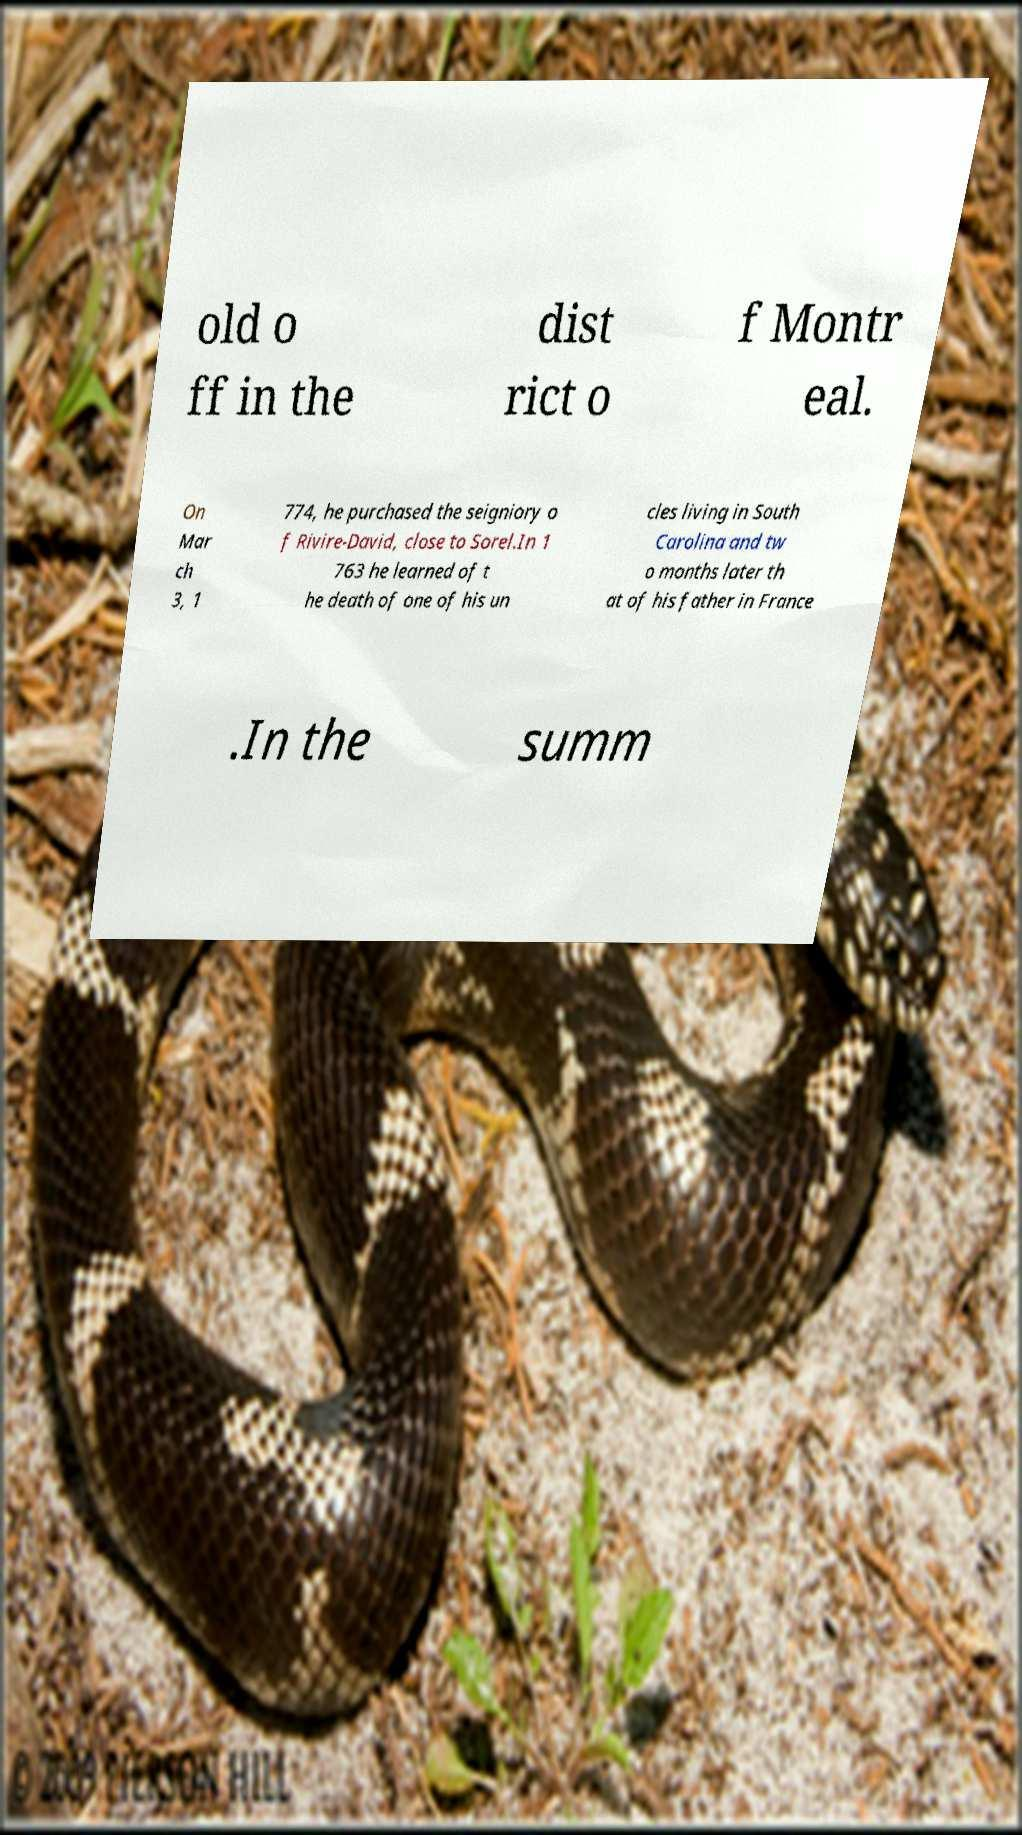Could you assist in decoding the text presented in this image and type it out clearly? old o ff in the dist rict o f Montr eal. On Mar ch 3, 1 774, he purchased the seigniory o f Rivire-David, close to Sorel.In 1 763 he learned of t he death of one of his un cles living in South Carolina and tw o months later th at of his father in France .In the summ 